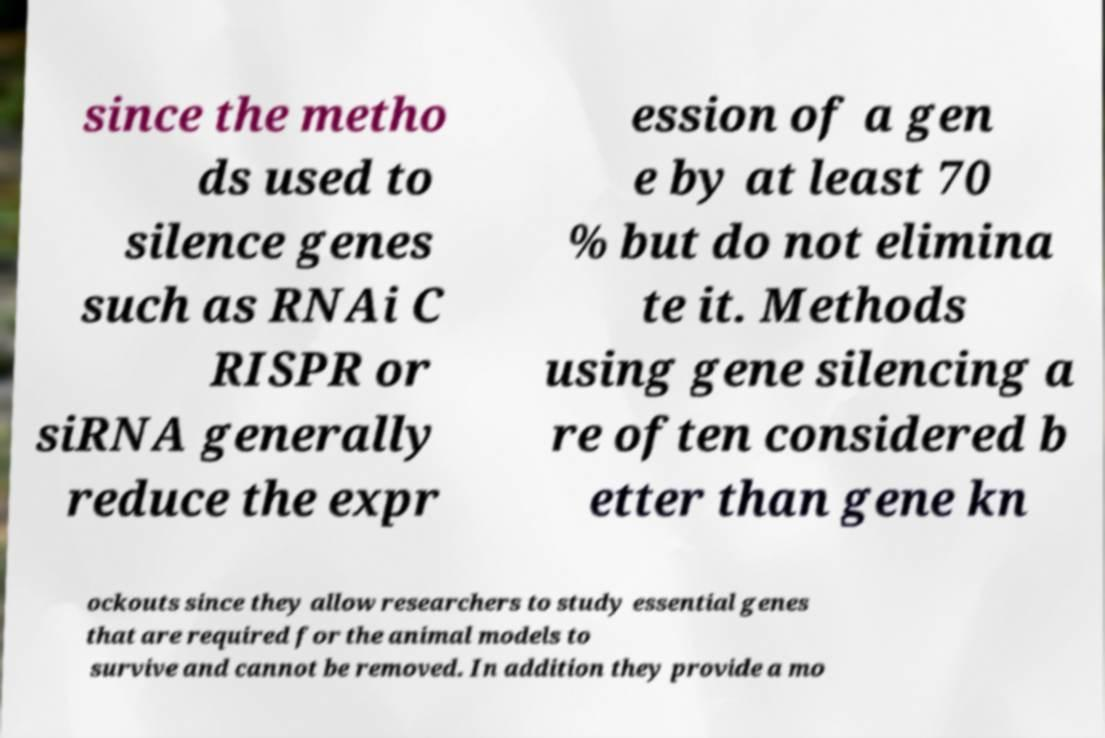There's text embedded in this image that I need extracted. Can you transcribe it verbatim? since the metho ds used to silence genes such as RNAi C RISPR or siRNA generally reduce the expr ession of a gen e by at least 70 % but do not elimina te it. Methods using gene silencing a re often considered b etter than gene kn ockouts since they allow researchers to study essential genes that are required for the animal models to survive and cannot be removed. In addition they provide a mo 